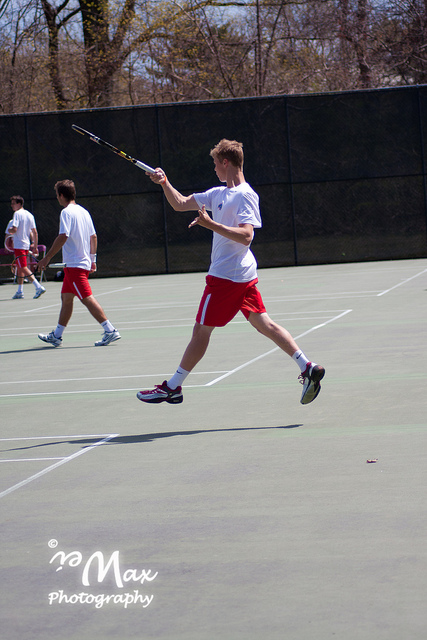Is this tennis court indoors or outdoors? The tennis court is outdoors, as we can see daylight and trees in the background.  What type of surface does the court have? The surface of the tennis court appears to be hard court, characterized by its smooth, flat finish typical of outdoor courts. 